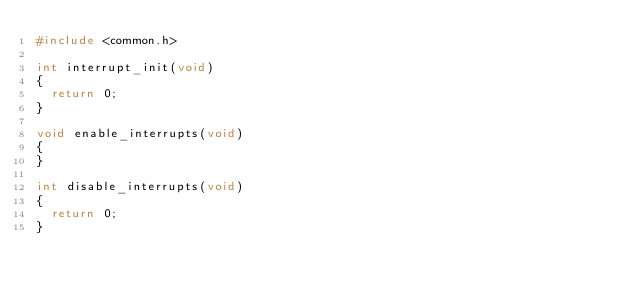<code> <loc_0><loc_0><loc_500><loc_500><_C_>#include <common.h>

int interrupt_init(void)
{
	return 0;
}

void enable_interrupts(void)
{
}

int disable_interrupts(void)
{
	return 0;
}
</code> 